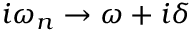Convert formula to latex. <formula><loc_0><loc_0><loc_500><loc_500>i \omega _ { n } \rightarrow \omega + i \delta</formula> 